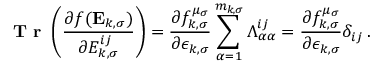Convert formula to latex. <formula><loc_0><loc_0><loc_500><loc_500>T r \left ( \frac { \partial f ( E _ { k , \sigma } ) } { \partial { E } _ { k , \sigma } ^ { i j } } \right ) = \frac { \partial f _ { k , \sigma } ^ { \mu _ { \sigma } } } { \partial \epsilon _ { k , \sigma } } \sum _ { \alpha = 1 } ^ { m _ { k , \sigma } } \Lambda _ { \alpha \alpha } ^ { i j } = \frac { \partial f _ { k , \sigma } ^ { \mu _ { \sigma } } } { \partial \epsilon _ { k , \sigma } } \delta _ { i j } \, .</formula> 